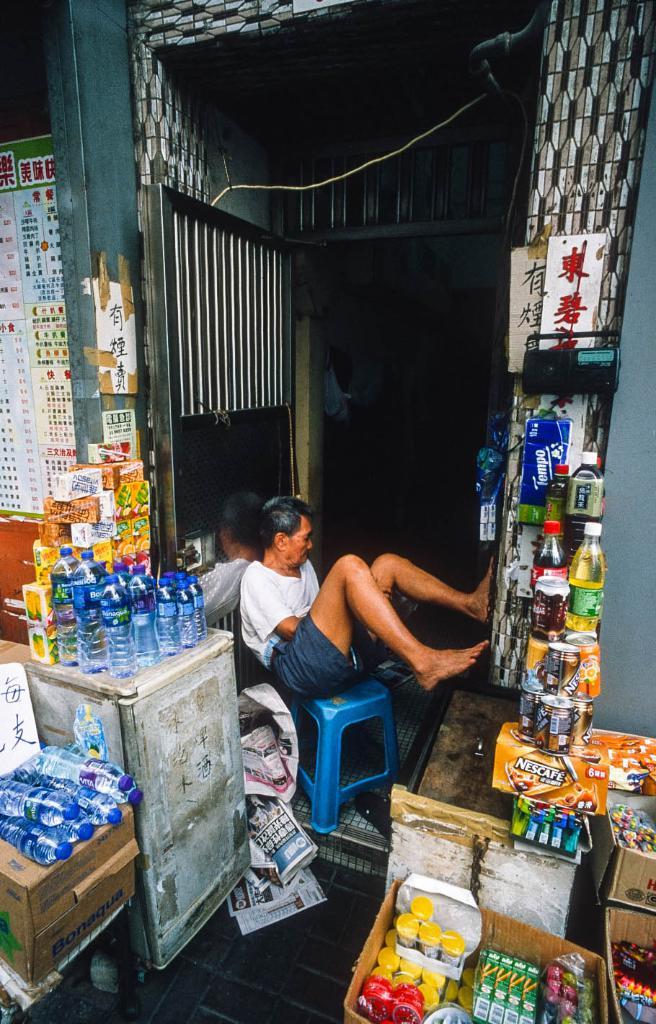What is the name on the orange box on the bottom right?
Make the answer very short. Nescafe. The boy watch the store?
Make the answer very short. Answering does not require reading text in the image. 